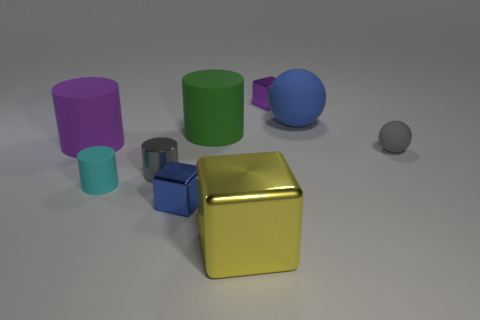What materials do the objects in the image appear to be made from? The objects in the image exhibit a variety of textures that suggest they could be made from different materials. The cubes and cylinders have a matte finish that resembles painted metal, while the spheres have a more reflective quality, indicating they might be made of a polished metal or plastic. 